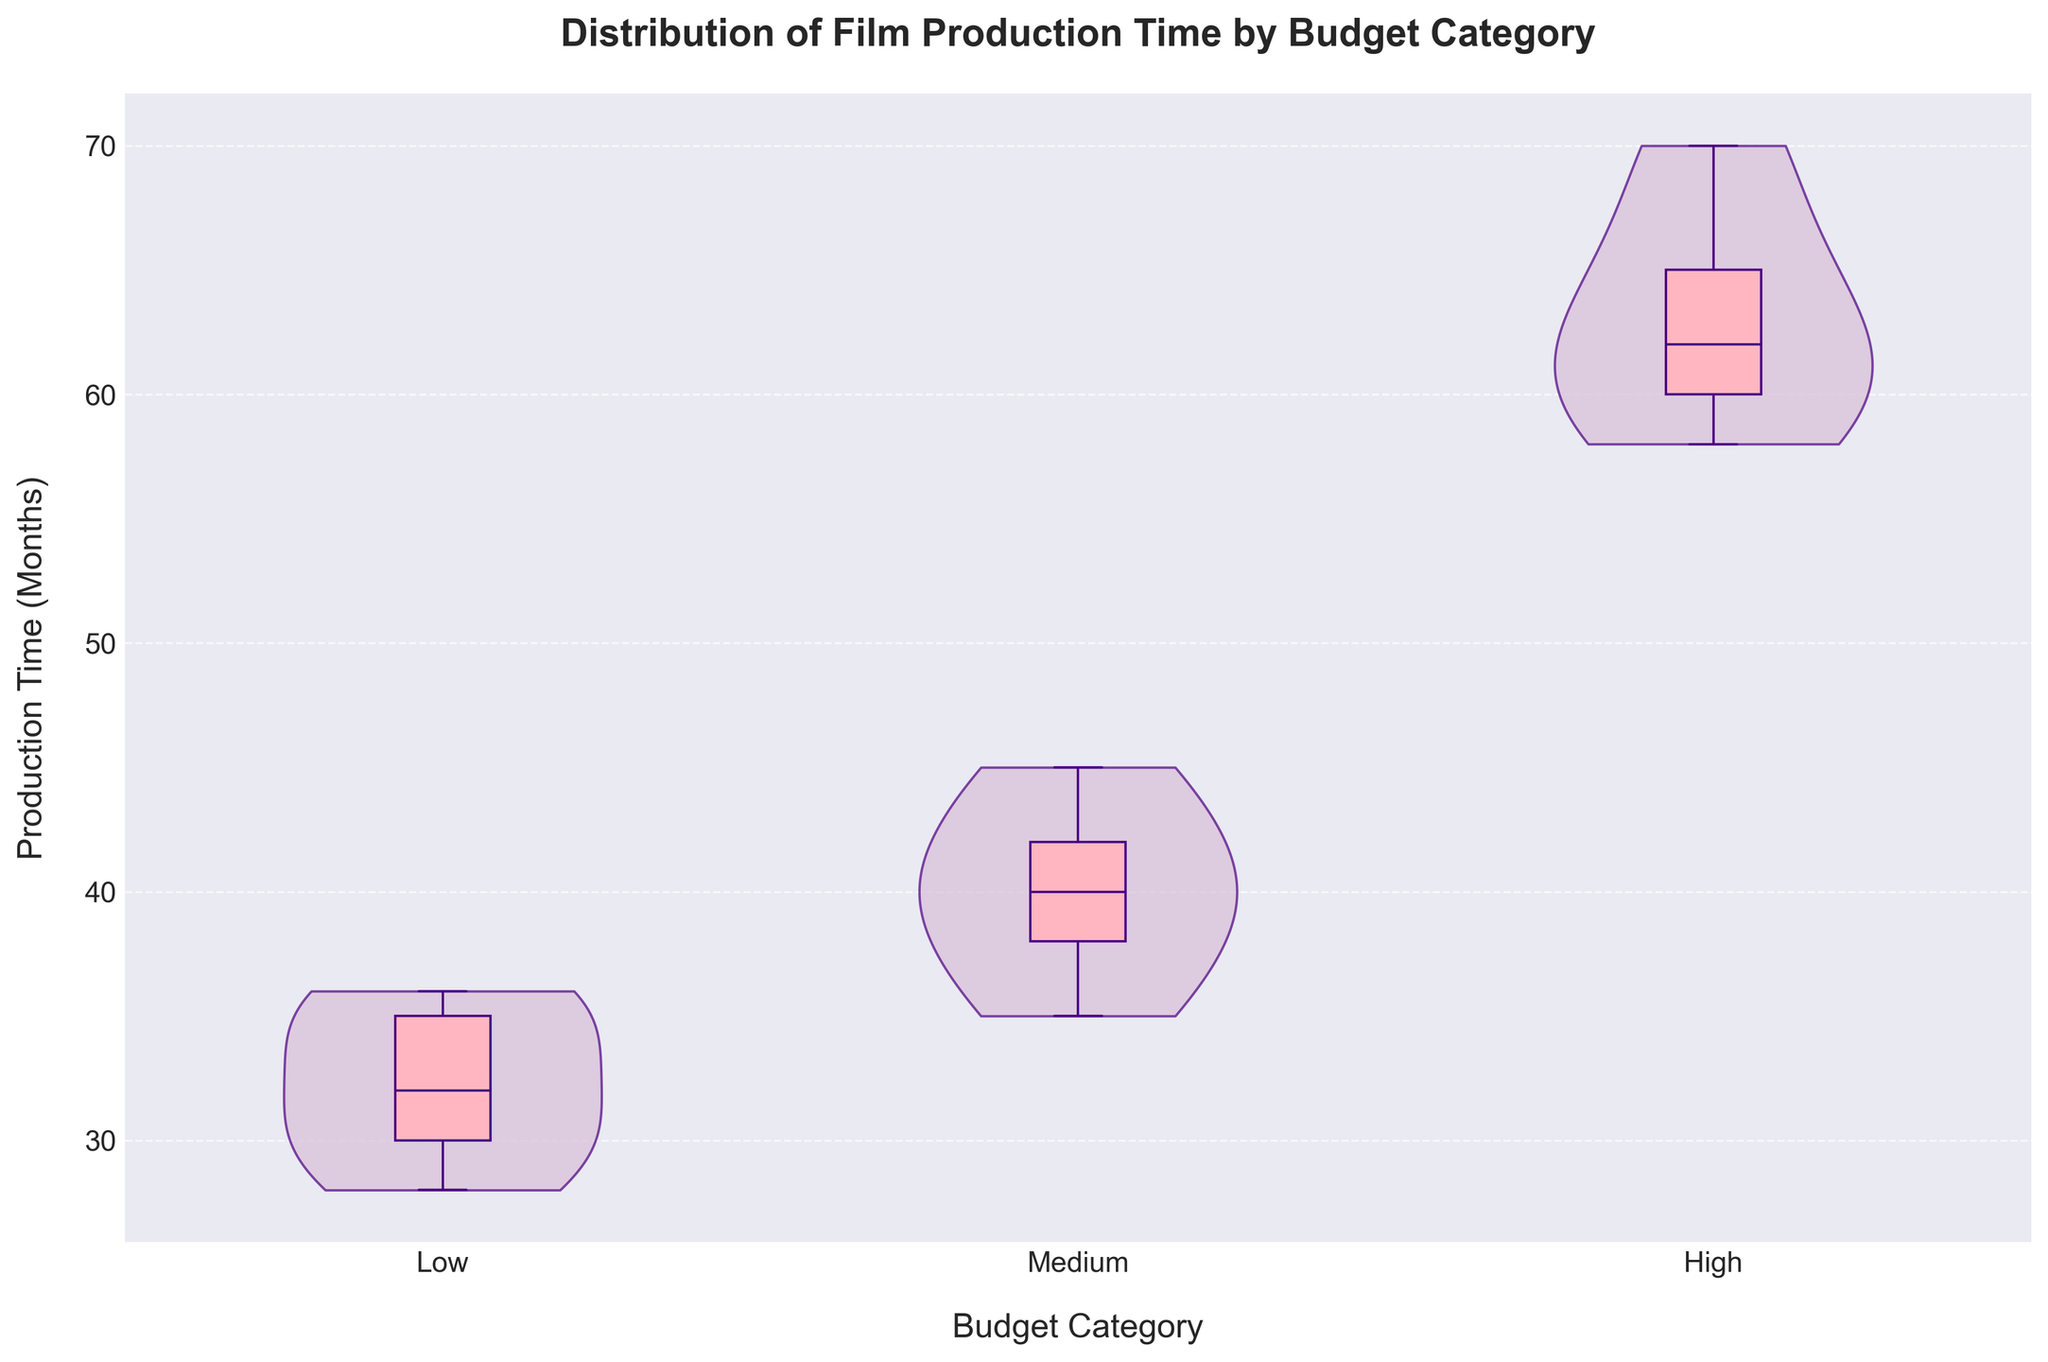What's the title of the plot? The title is located at the top of the figure.
Answer: Distribution of Film Production Time by Budget Category Which budget category has the longest production time? The high budget category has the longest production times, with the median production time noticeably longer than other categories. This is evident from the position of the central box and the spread of the violin plot in this category.
Answer: High What is the median production time for medium-budget films? To find the median, we need to check the position of the thick horizontal line inside the box plot for medium-budget films. It appears to be around 40 months.
Answer: 40 months How many budget categories are displayed in the plot? We can count the distinct categories on the x-axis to determine the number of budget categories. There are three categories shown.
Answer: Three Which budget category has the narrowest interquartile range (IQR) of production times? We need to compare the width of the boxes (which represent the IQR) across the categories. The medium budget category has the narrowest box, indicating the smallest IQR.
Answer: Medium Which film has the longest production time and what is it? By looking at the annotated film titles and their corresponding y-values in the high budget category, we see "Mad Max: Fury Road" with a production time around 70 months.
Answer: Mad Max: Fury Road, 70 months Compare the production time spread of low-budget and high-budget films. Which has a larger variance? The variance can be inferred from the width and shape of the violin plots; high-budget films show a wider spread, indicating larger variance compared to low-budget films which have a narrower spread.
Answer: High-budget films What is the approximate range of production times for low-budget films? The range can be deduced from the bottom to the top ends of the violin plot for low-budget films, which is approximately from 28 to 36 months.
Answer: 28 to 36 months Are there any outliers in the low-budget films’ production time data? We can identify outliers by looking for data points outside the whiskers of the box plot for low-budget films, but none are visible, indicating no outliers.
Answer: No Does the medium budget category have any films with a production time longer than 45 months? By observing the upper extent of the violin and the box plot in the medium category, it is clear no data points exceed 45 months.
Answer: No 